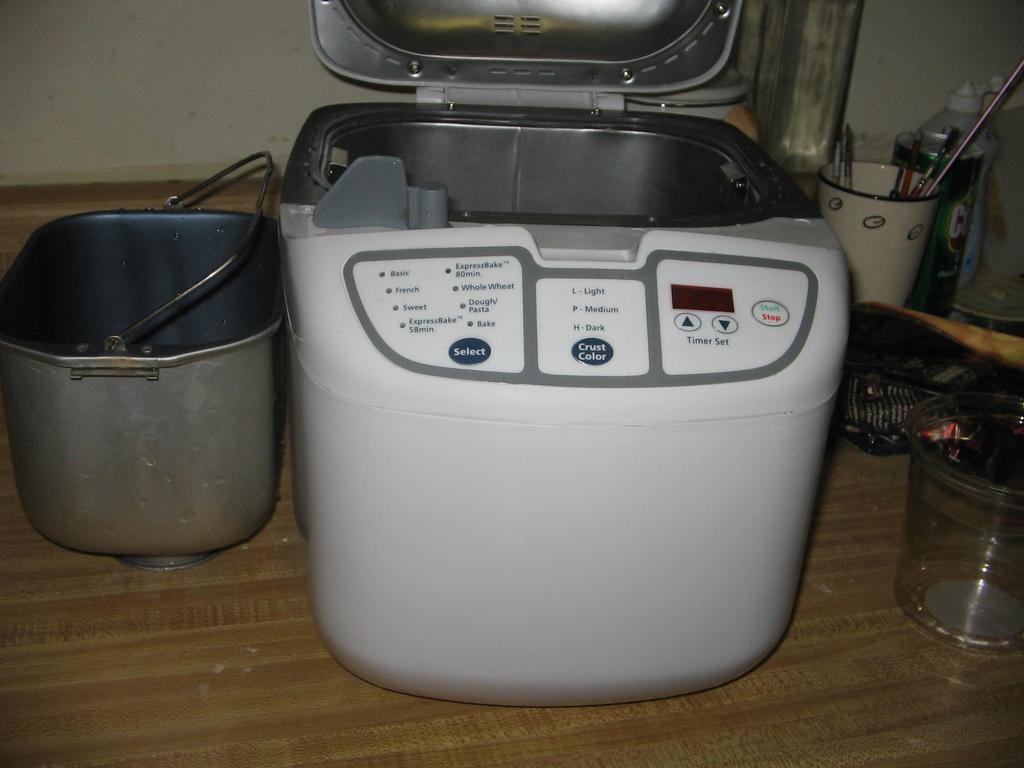What is on the left most button?
Give a very brief answer. Select. What are the two words in green and red?
Give a very brief answer. Start stop. 